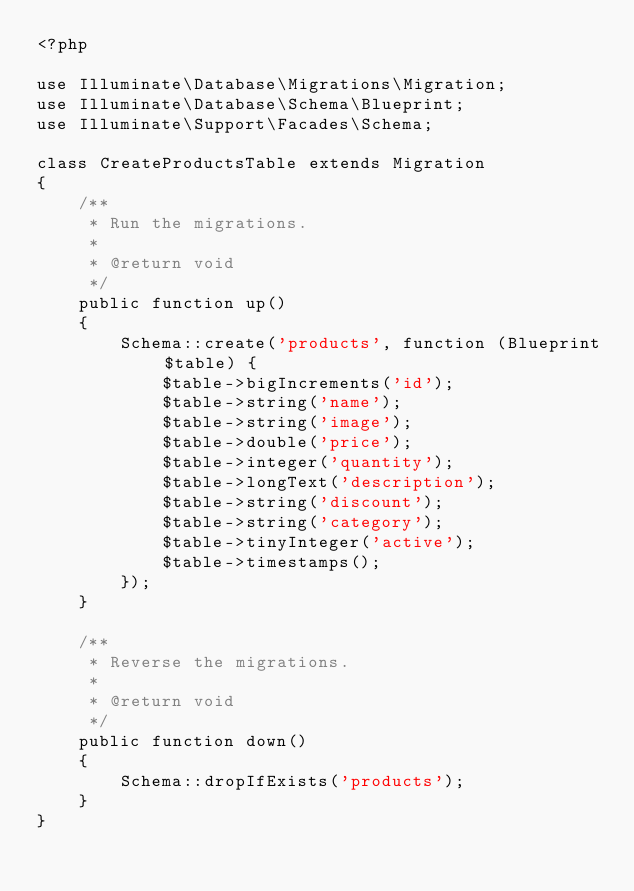<code> <loc_0><loc_0><loc_500><loc_500><_PHP_><?php

use Illuminate\Database\Migrations\Migration;
use Illuminate\Database\Schema\Blueprint;
use Illuminate\Support\Facades\Schema;

class CreateProductsTable extends Migration
{
    /**
     * Run the migrations.
     *
     * @return void
     */
    public function up()
    {
        Schema::create('products', function (Blueprint $table) {
            $table->bigIncrements('id');
            $table->string('name');
            $table->string('image');
            $table->double('price');
            $table->integer('quantity');
            $table->longText('description');
            $table->string('discount');
            $table->string('category');
            $table->tinyInteger('active');
            $table->timestamps();
        });
    }

    /**
     * Reverse the migrations.
     *
     * @return void
     */
    public function down()
    {
        Schema::dropIfExists('products');
    }
}
</code> 